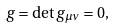Convert formula to latex. <formula><loc_0><loc_0><loc_500><loc_500>g = \det g _ { \mu \nu } = 0 ,</formula> 